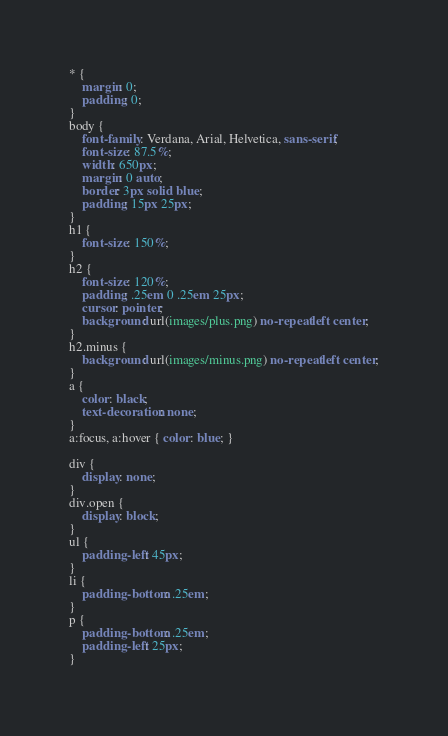Convert code to text. <code><loc_0><loc_0><loc_500><loc_500><_CSS_>* {
    margin: 0;
    padding: 0;
}
body {
    font-family: Verdana, Arial, Helvetica, sans-serif;
    font-size: 87.5%;
    width: 650px;
    margin: 0 auto;
    border: 3px solid blue;
    padding: 15px 25px;
}
h1 { 
    font-size: 150%;
}
h2 {
    font-size: 120%;
    padding: .25em 0 .25em 25px;
    cursor: pointer;
    background: url(images/plus.png) no-repeat left center;
}
h2.minus {
    background: url(images/minus.png) no-repeat left center;
}
a {
    color: black;
    text-decoration: none; 
}
a:focus, a:hover { color: blue; }

div {
    display: none;
}
div.open {
    display: block;
}
ul {
    padding-left: 45px;
}
li {
    padding-bottom: .25em;
}
p {
    padding-bottom: .25em;
    padding-left: 25px;
}
</code> 